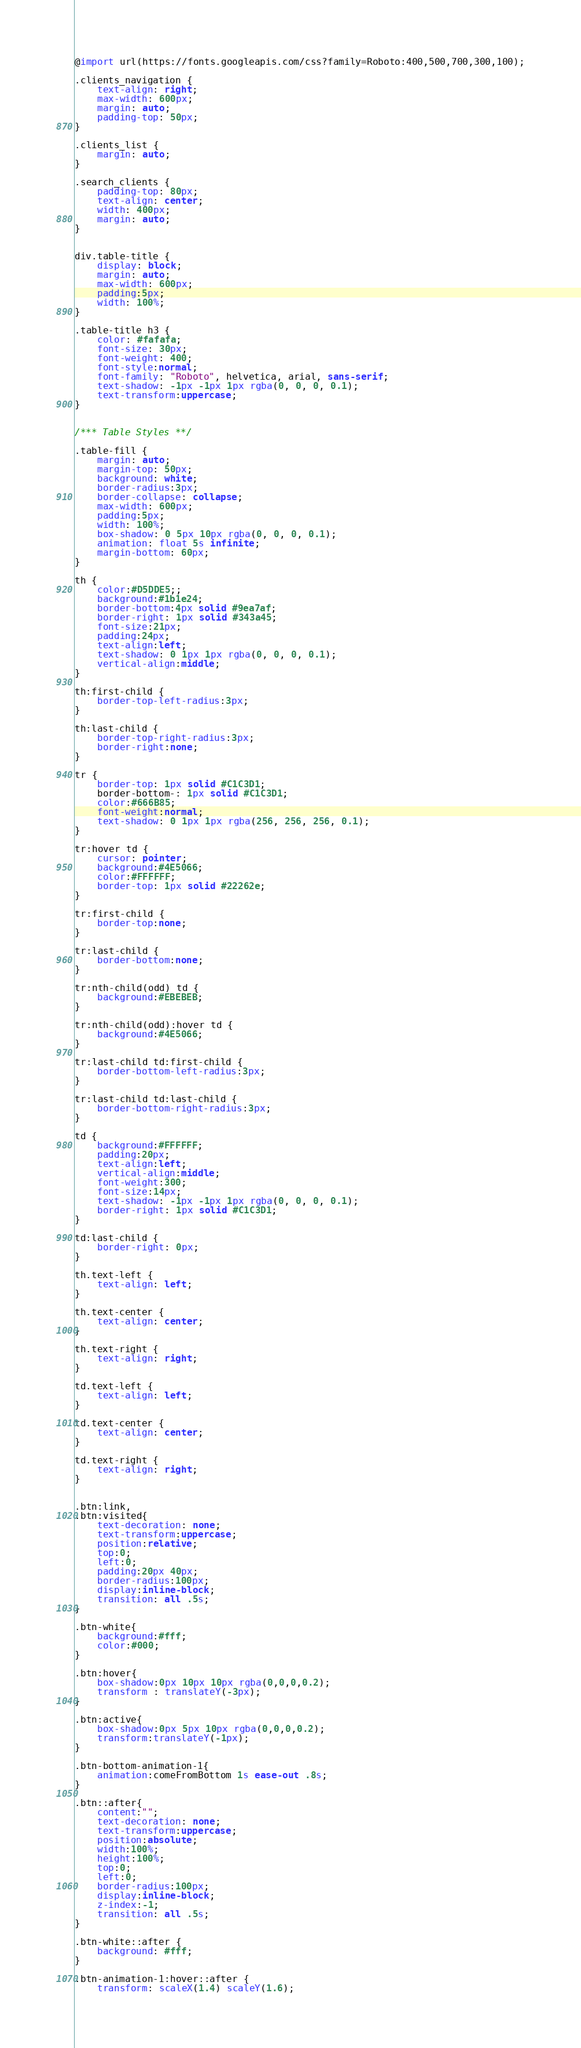<code> <loc_0><loc_0><loc_500><loc_500><_CSS_>@import url(https://fonts.googleapis.com/css?family=Roboto:400,500,700,300,100);

.clients_navigation {
    text-align: right;
    max-width: 600px;
    margin: auto;
    padding-top: 50px;
}

.clients_list {
    margin: auto;
}

.search_clients {
    padding-top: 80px;
    text-align: center;
    width: 400px;
    margin: auto;
}


div.table-title {
    display: block;
    margin: auto;
    max-width: 600px;
    padding:5px;
    width: 100%;
}

.table-title h3 {
    color: #fafafa;
    font-size: 30px;
    font-weight: 400;
    font-style:normal;
    font-family: "Roboto", helvetica, arial, sans-serif;
    text-shadow: -1px -1px 1px rgba(0, 0, 0, 0.1);
    text-transform:uppercase;
}


/*** Table Styles **/

.table-fill {
    margin: auto;
    margin-top: 50px;
    background: white;
    border-radius:3px;
    border-collapse: collapse;
    max-width: 600px;
    padding:5px;
    width: 100%;
    box-shadow: 0 5px 10px rgba(0, 0, 0, 0.1);
    animation: float 5s infinite;
    margin-bottom: 60px;
}

th {
    color:#D5DDE5;;
    background:#1b1e24;
    border-bottom:4px solid #9ea7af;
    border-right: 1px solid #343a45;
    font-size:21px;
    padding:24px;
    text-align:left;
    text-shadow: 0 1px 1px rgba(0, 0, 0, 0.1);
    vertical-align:middle;
}

th:first-child {
    border-top-left-radius:3px;
}

th:last-child {
    border-top-right-radius:3px;
    border-right:none;
}

tr {
    border-top: 1px solid #C1C3D1;
    border-bottom-: 1px solid #C1C3D1;
    color:#666B85;
    font-weight:normal;
    text-shadow: 0 1px 1px rgba(256, 256, 256, 0.1);
}

tr:hover td {
    cursor: pointer;
    background:#4E5066;
    color:#FFFFFF;
    border-top: 1px solid #22262e;
}

tr:first-child {
    border-top:none;
}

tr:last-child {
    border-bottom:none;
}

tr:nth-child(odd) td {
    background:#EBEBEB;
}

tr:nth-child(odd):hover td {
    background:#4E5066;
}

tr:last-child td:first-child {
    border-bottom-left-radius:3px;
}

tr:last-child td:last-child {
    border-bottom-right-radius:3px;
}

td {
    background:#FFFFFF;
    padding:20px;
    text-align:left;
    vertical-align:middle;
    font-weight:300;
    font-size:14px;
    text-shadow: -1px -1px 1px rgba(0, 0, 0, 0.1);
    border-right: 1px solid #C1C3D1;
}

td:last-child {
    border-right: 0px;
}

th.text-left {
    text-align: left;
}

th.text-center {
    text-align: center;
}

th.text-right {
    text-align: right;
}

td.text-left {
    text-align: left;
}

td.text-center {
    text-align: center;
}

td.text-right {
    text-align: right;
}


.btn:link,
.btn:visited{
    text-decoration: none;
    text-transform:uppercase;
    position:relative;
    top:0;
    left:0;
    padding:20px 40px;
    border-radius:100px;
    display:inline-block;
    transition: all .5s;
}

.btn-white{
    background:#fff;
    color:#000;
}

.btn:hover{
    box-shadow:0px 10px 10px rgba(0,0,0,0.2);
    transform : translateY(-3px);
}

.btn:active{
    box-shadow:0px 5px 10px rgba(0,0,0,0.2);
    transform:translateY(-1px);
}

.btn-bottom-animation-1{
    animation:comeFromBottom 1s ease-out .8s;
}

.btn::after{
    content:"";
    text-decoration: none;
    text-transform:uppercase;
    position:absolute;
    width:100%;
    height:100%;
    top:0;
    left:0;
    border-radius:100px;
    display:inline-block;
    z-index:-1;
    transition: all .5s;
}

.btn-white::after {
    background: #fff;
}

.btn-animation-1:hover::after {
    transform: scaleX(1.4) scaleY(1.6);</code> 